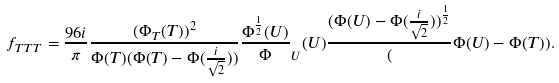Convert formula to latex. <formula><loc_0><loc_0><loc_500><loc_500>f _ { T T T } = \frac { 9 6 i } { \pi } \frac { ( \Phi _ { T } ( T ) ) ^ { 2 } } { \Phi ( T ) ( \Phi ( T ) - \Phi ( \frac { i } { \sqrt { 2 } } ) ) } \frac { \Phi ^ { \frac { 1 } { 2 } } ( U ) } \Phi _ { U } ( U ) \frac { ( \Phi ( U ) - \Phi ( \frac { i } { \sqrt { 2 } } ) ) ^ { \frac { 1 } { 2 } } } ( \Phi ( U ) - \Phi ( T ) ) .</formula> 